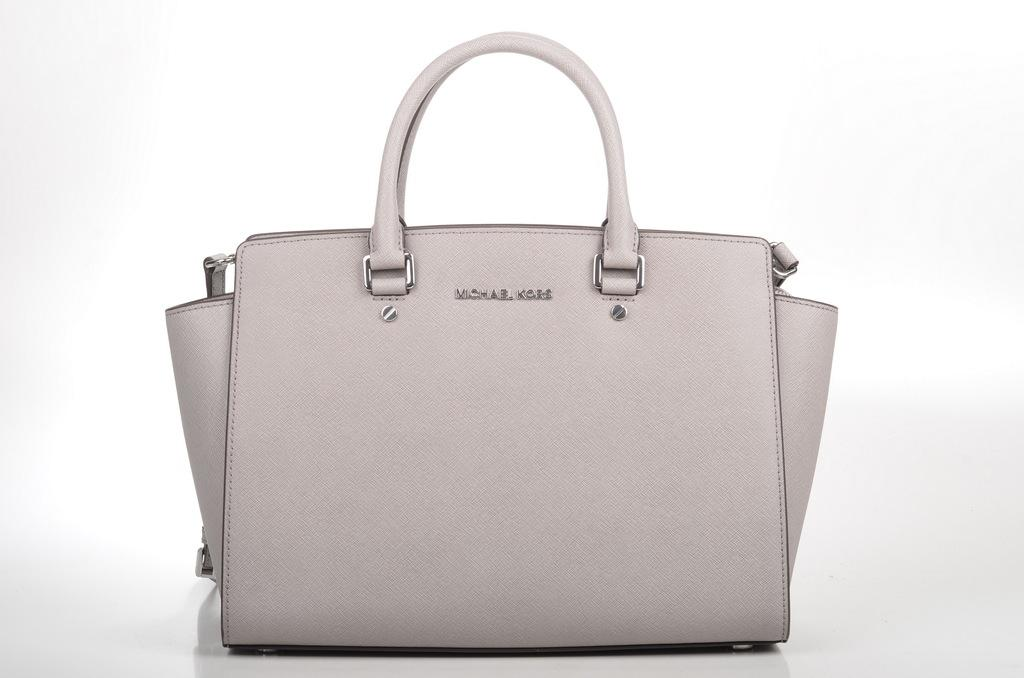What object can be seen in the image? There is a handbag in the image. What type of pest can be seen crawling on the desk in the image? There is no desk or pest present in the image; it only features a handbag. 